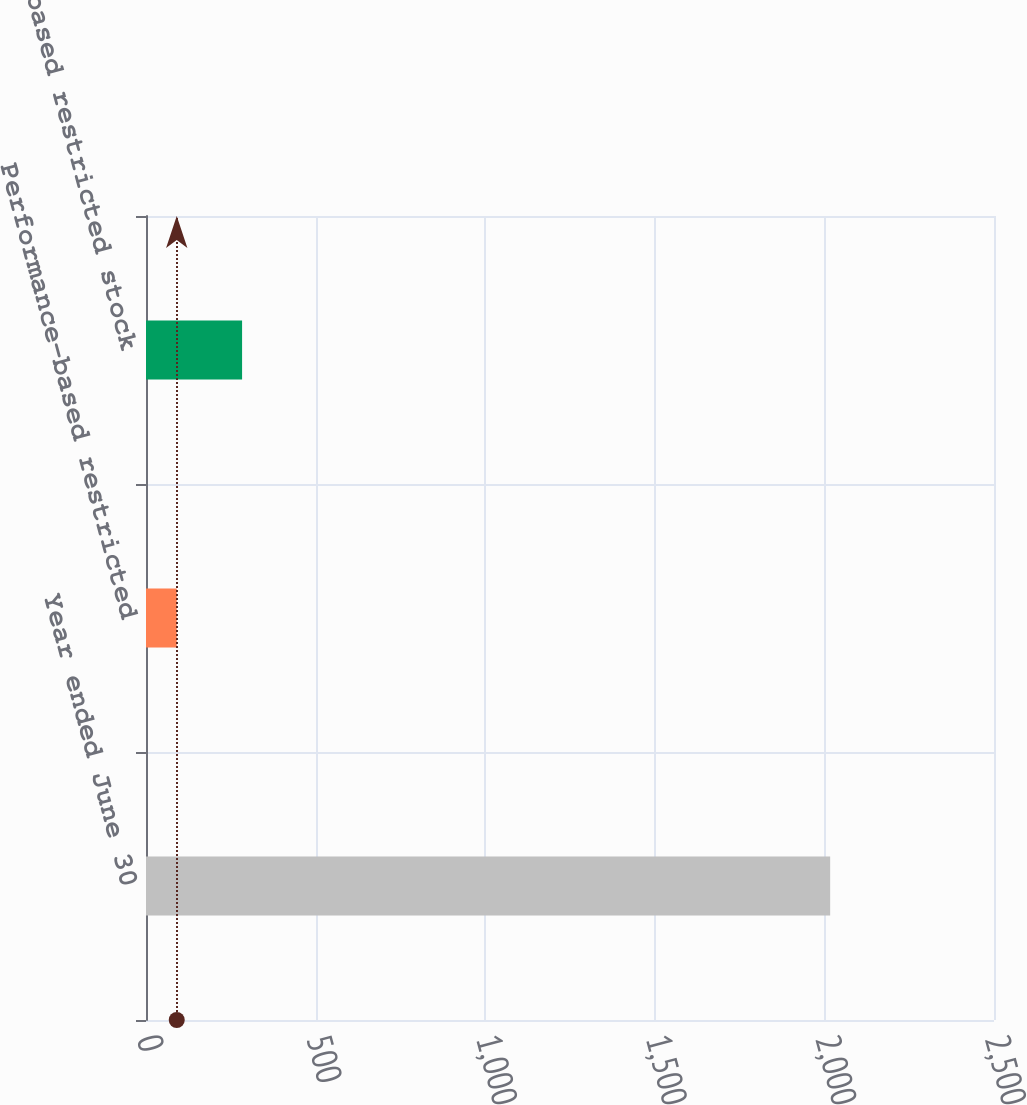<chart> <loc_0><loc_0><loc_500><loc_500><bar_chart><fcel>Year ended June 30<fcel>Performance-based restricted<fcel>Time-based restricted stock<nl><fcel>2017<fcel>90.63<fcel>283.27<nl></chart> 